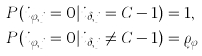<formula> <loc_0><loc_0><loc_500><loc_500>& P ( i _ { \varphi , j } = 0 | i _ { \delta , j } = C - 1 ) = 1 , \\ & P ( i _ { \varphi , j } = 0 | i _ { \delta , j } \neq C - 1 ) = \varrho _ { \varphi }</formula> 